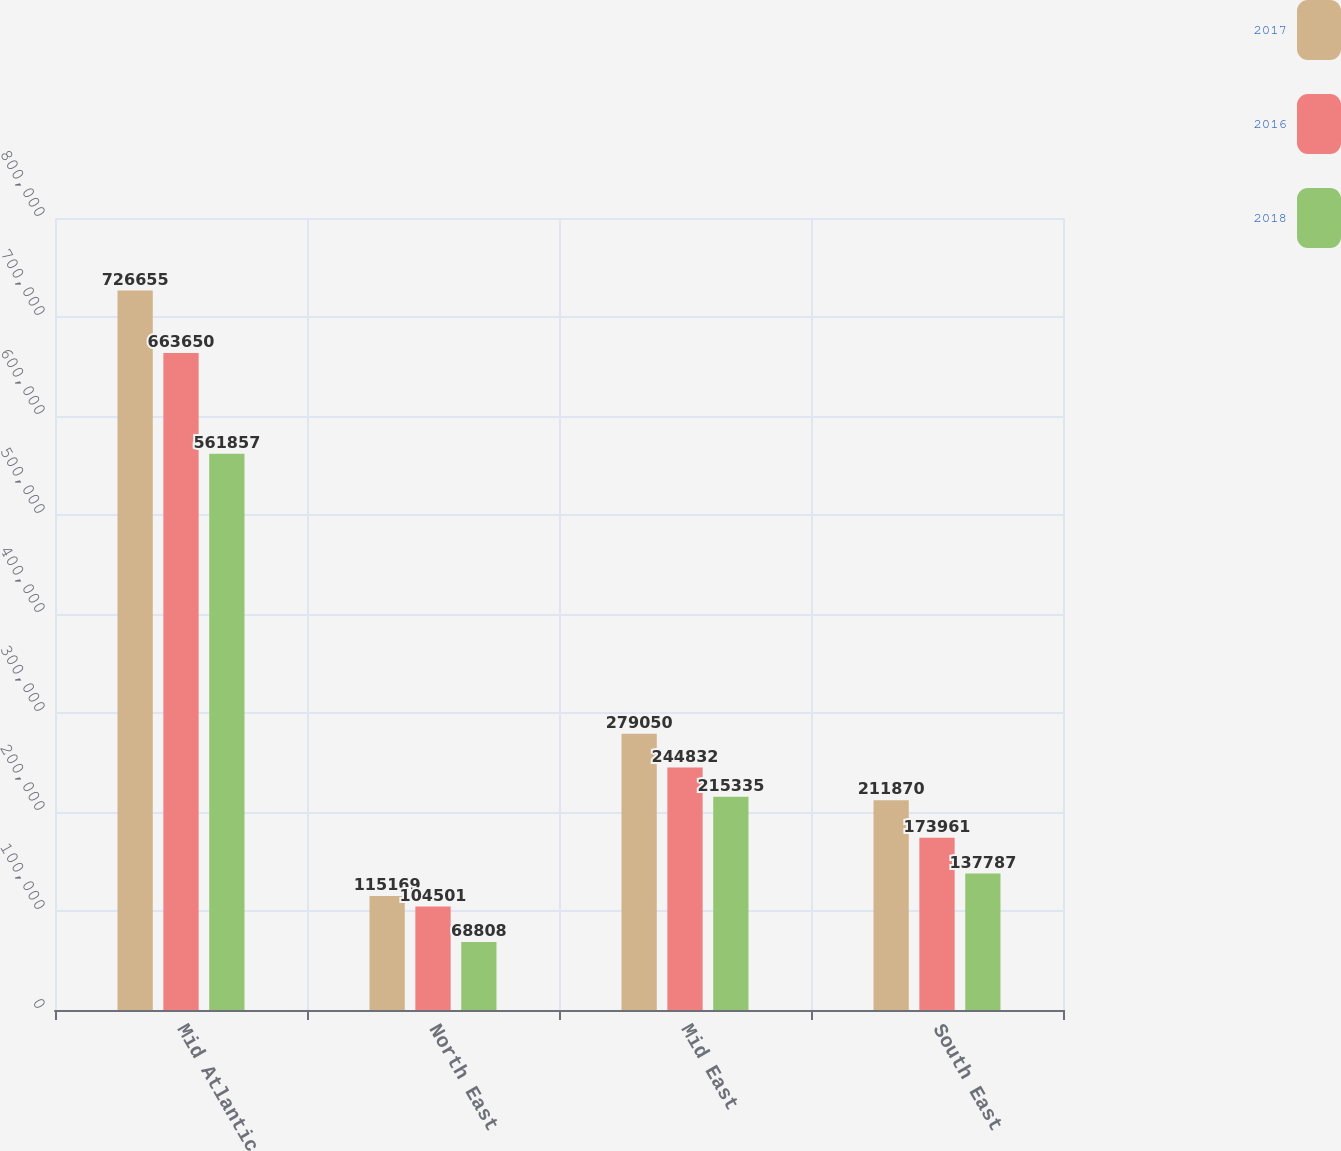Convert chart to OTSL. <chart><loc_0><loc_0><loc_500><loc_500><stacked_bar_chart><ecel><fcel>Mid Atlantic<fcel>North East<fcel>Mid East<fcel>South East<nl><fcel>2017<fcel>726655<fcel>115169<fcel>279050<fcel>211870<nl><fcel>2016<fcel>663650<fcel>104501<fcel>244832<fcel>173961<nl><fcel>2018<fcel>561857<fcel>68808<fcel>215335<fcel>137787<nl></chart> 